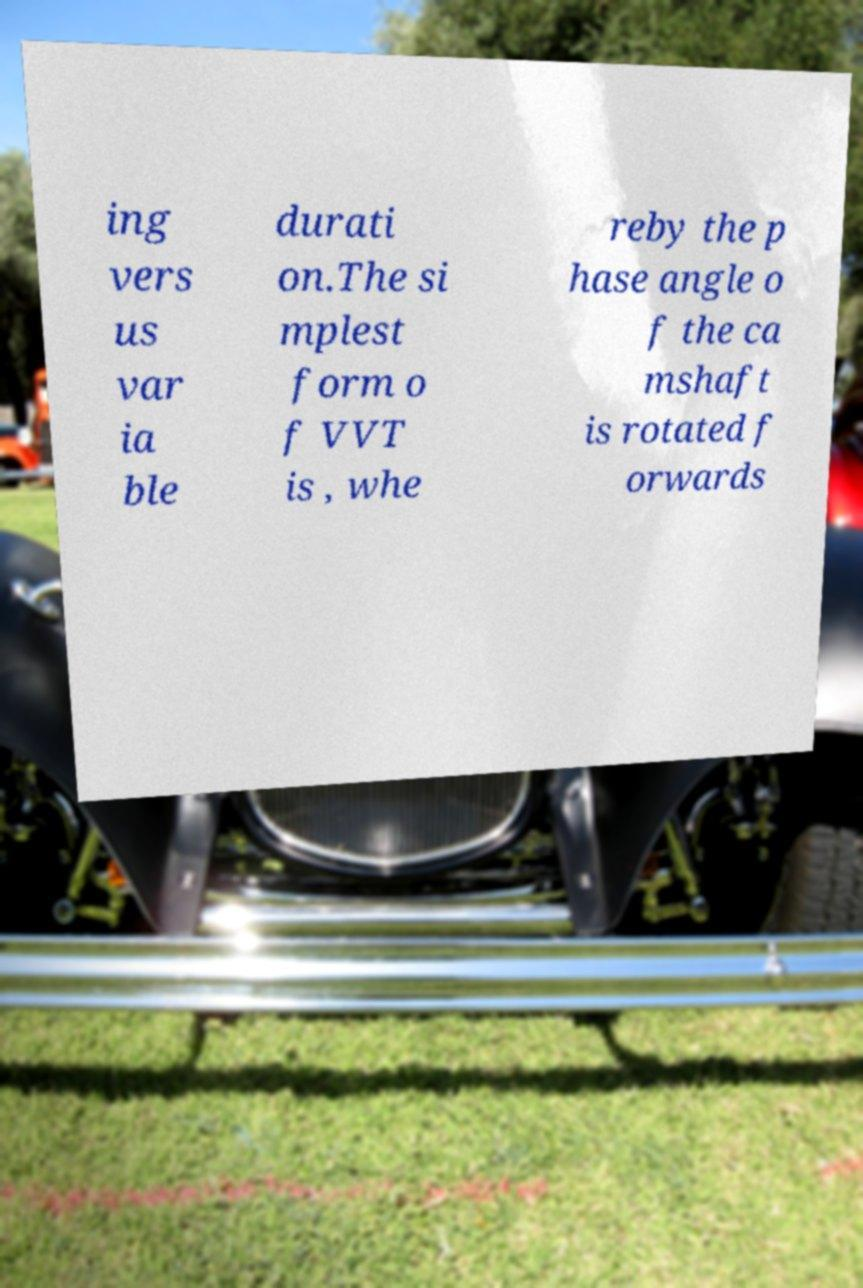I need the written content from this picture converted into text. Can you do that? ing vers us var ia ble durati on.The si mplest form o f VVT is , whe reby the p hase angle o f the ca mshaft is rotated f orwards 